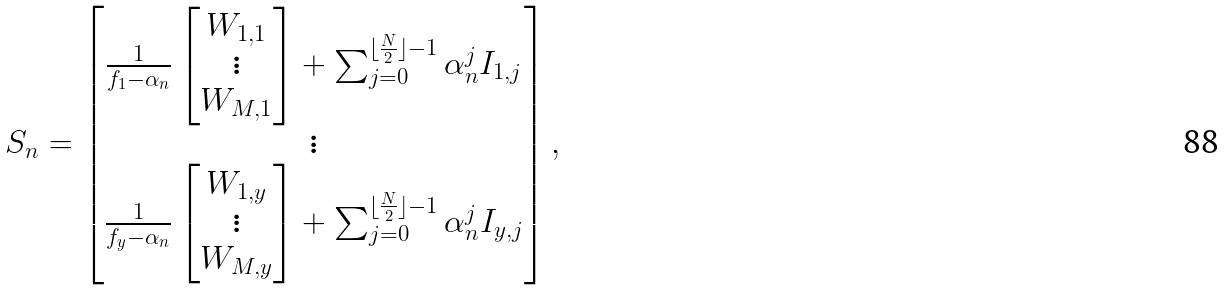Convert formula to latex. <formula><loc_0><loc_0><loc_500><loc_500>S _ { n } = \begin{bmatrix} \frac { 1 } { f _ { 1 } - \alpha _ { n } } \begin{bmatrix} W _ { 1 , 1 } \\ \vdots \\ W _ { M , 1 } \end{bmatrix} + \sum _ { j = 0 } ^ { \lfloor \frac { N } { 2 } \rfloor - 1 } \alpha _ { n } ^ { j } I _ { 1 , j } \\ \vdots \\ \frac { 1 } { f _ { y } - \alpha _ { n } } \begin{bmatrix} W _ { 1 , y } \\ \vdots \\ W _ { M , y } \end{bmatrix} + \sum _ { j = 0 } ^ { \lfloor \frac { N } { 2 } \rfloor - 1 } \alpha _ { n } ^ { j } I _ { y , j } \end{bmatrix} ,</formula> 